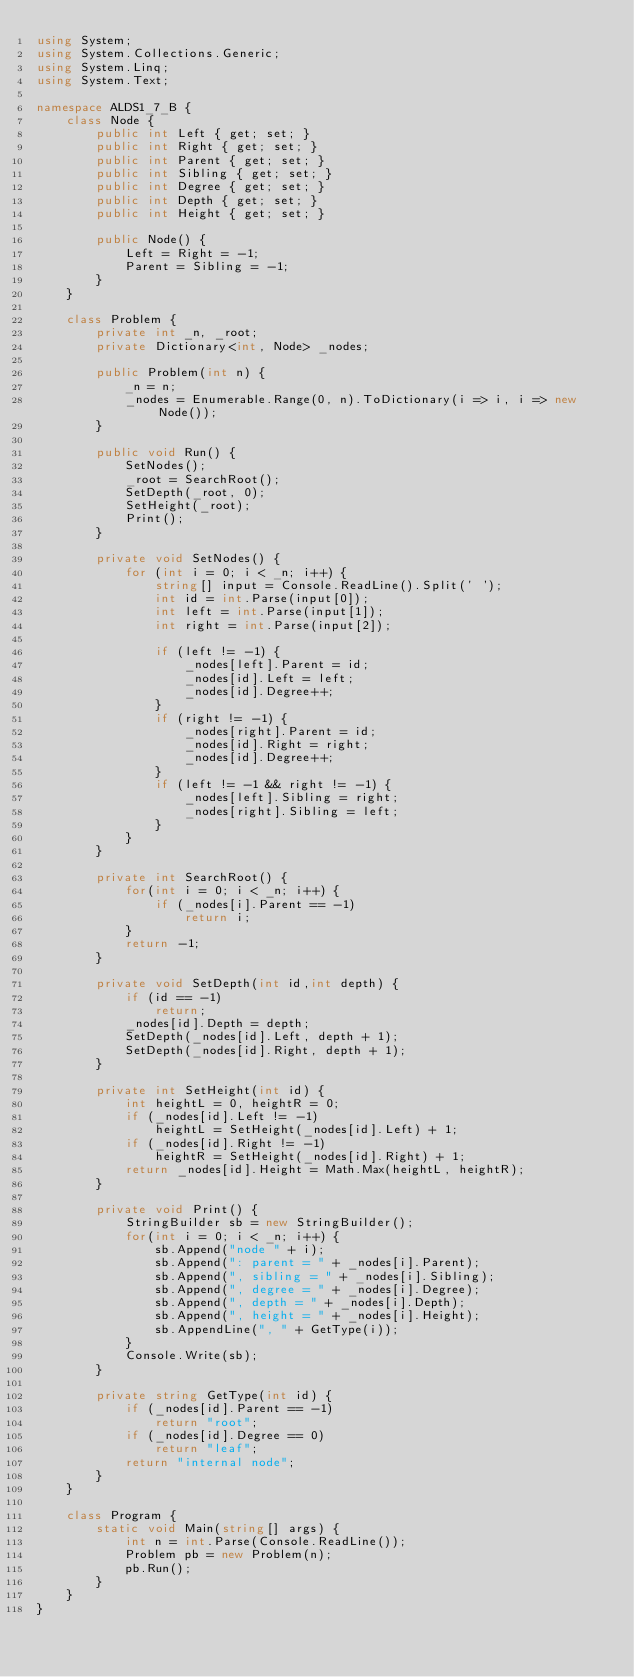Convert code to text. <code><loc_0><loc_0><loc_500><loc_500><_C#_>using System;
using System.Collections.Generic;
using System.Linq;
using System.Text;

namespace ALDS1_7_B {
    class Node {
        public int Left { get; set; }
        public int Right { get; set; }
        public int Parent { get; set; }
        public int Sibling { get; set; }
        public int Degree { get; set; }
        public int Depth { get; set; }
        public int Height { get; set; }

        public Node() {
            Left = Right = -1;
            Parent = Sibling = -1;
        }
    }

    class Problem {
        private int _n, _root;
        private Dictionary<int, Node> _nodes;

        public Problem(int n) {
            _n = n;
            _nodes = Enumerable.Range(0, n).ToDictionary(i => i, i => new Node());
        }

        public void Run() {
            SetNodes();
            _root = SearchRoot();
            SetDepth(_root, 0);
            SetHeight(_root);
            Print();
        }

        private void SetNodes() {
            for (int i = 0; i < _n; i++) {
                string[] input = Console.ReadLine().Split(' ');
                int id = int.Parse(input[0]);
                int left = int.Parse(input[1]);
                int right = int.Parse(input[2]);

                if (left != -1) {
                    _nodes[left].Parent = id;
                    _nodes[id].Left = left;
                    _nodes[id].Degree++;
                }
                if (right != -1) {
                    _nodes[right].Parent = id;
                    _nodes[id].Right = right;
                    _nodes[id].Degree++;
                }
                if (left != -1 && right != -1) {
                    _nodes[left].Sibling = right;
                    _nodes[right].Sibling = left;
                }
            }
        }

        private int SearchRoot() {
            for(int i = 0; i < _n; i++) {
                if (_nodes[i].Parent == -1)
                    return i;
            }
            return -1;
        }

        private void SetDepth(int id,int depth) {
            if (id == -1)
                return;
            _nodes[id].Depth = depth;
            SetDepth(_nodes[id].Left, depth + 1);
            SetDepth(_nodes[id].Right, depth + 1);
        }

        private int SetHeight(int id) {
            int heightL = 0, heightR = 0;
            if (_nodes[id].Left != -1)
                heightL = SetHeight(_nodes[id].Left) + 1;
            if (_nodes[id].Right != -1)
                heightR = SetHeight(_nodes[id].Right) + 1;
            return _nodes[id].Height = Math.Max(heightL, heightR);
        }

        private void Print() {
            StringBuilder sb = new StringBuilder();
            for(int i = 0; i < _n; i++) {
                sb.Append("node " + i);
                sb.Append(": parent = " + _nodes[i].Parent);
                sb.Append(", sibling = " + _nodes[i].Sibling);
                sb.Append(", degree = " + _nodes[i].Degree);
                sb.Append(", depth = " + _nodes[i].Depth);
                sb.Append(", height = " + _nodes[i].Height);
                sb.AppendLine(", " + GetType(i));
            }
            Console.Write(sb);
        }

        private string GetType(int id) {
            if (_nodes[id].Parent == -1)
                return "root";
            if (_nodes[id].Degree == 0)
                return "leaf";
            return "internal node";
        }
    }

    class Program {
        static void Main(string[] args) {
            int n = int.Parse(Console.ReadLine());
            Problem pb = new Problem(n);
            pb.Run();
        }
    }
}</code> 